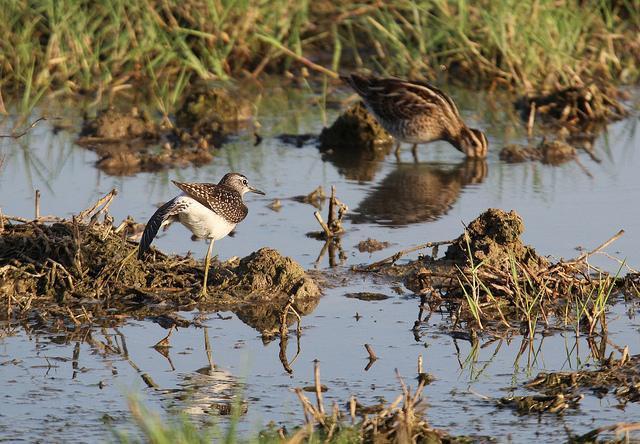How many birds are in the photo?
Give a very brief answer. 2. 